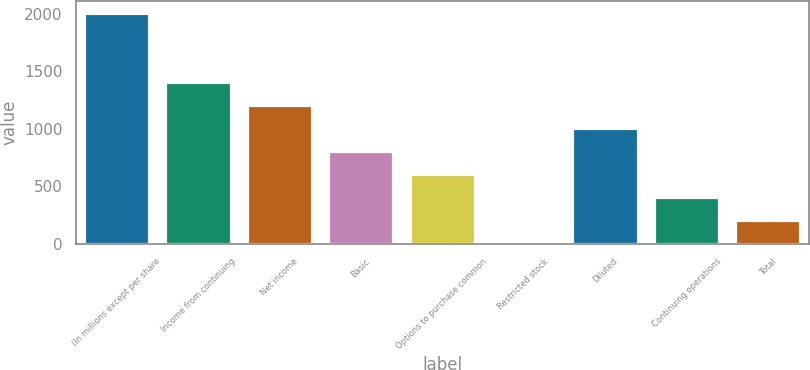<chart> <loc_0><loc_0><loc_500><loc_500><bar_chart><fcel>(In millions except per share<fcel>Income from continuing<fcel>Net income<fcel>Basic<fcel>Options to purchase common<fcel>Restricted stock<fcel>Diluted<fcel>Continuing operations<fcel>Total<nl><fcel>2007<fcel>1405.2<fcel>1204.6<fcel>803.4<fcel>602.8<fcel>1<fcel>1004<fcel>402.2<fcel>201.6<nl></chart> 